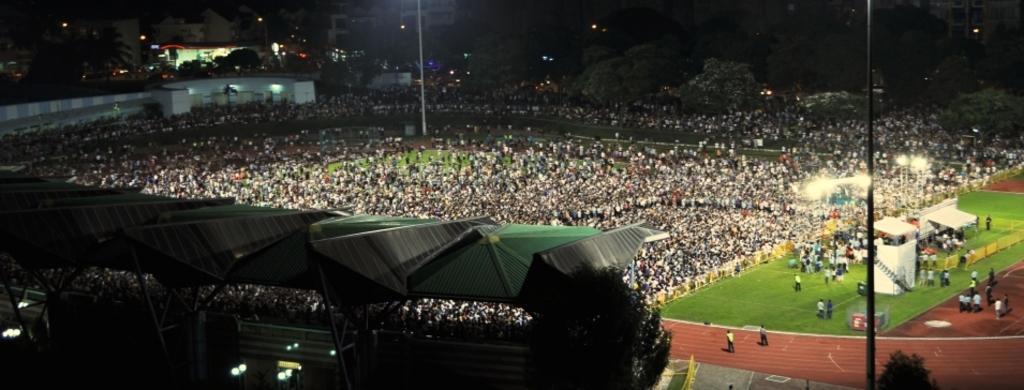Could you give a brief overview of what you see in this image? In this image we can see a crowd. Also there is a shed with rods. Also there are trees. And there are light poles. In the background there are buildings and trees. Also there are lights. At the bottom we can see an athletic track. Also we can see grass on the ground. 